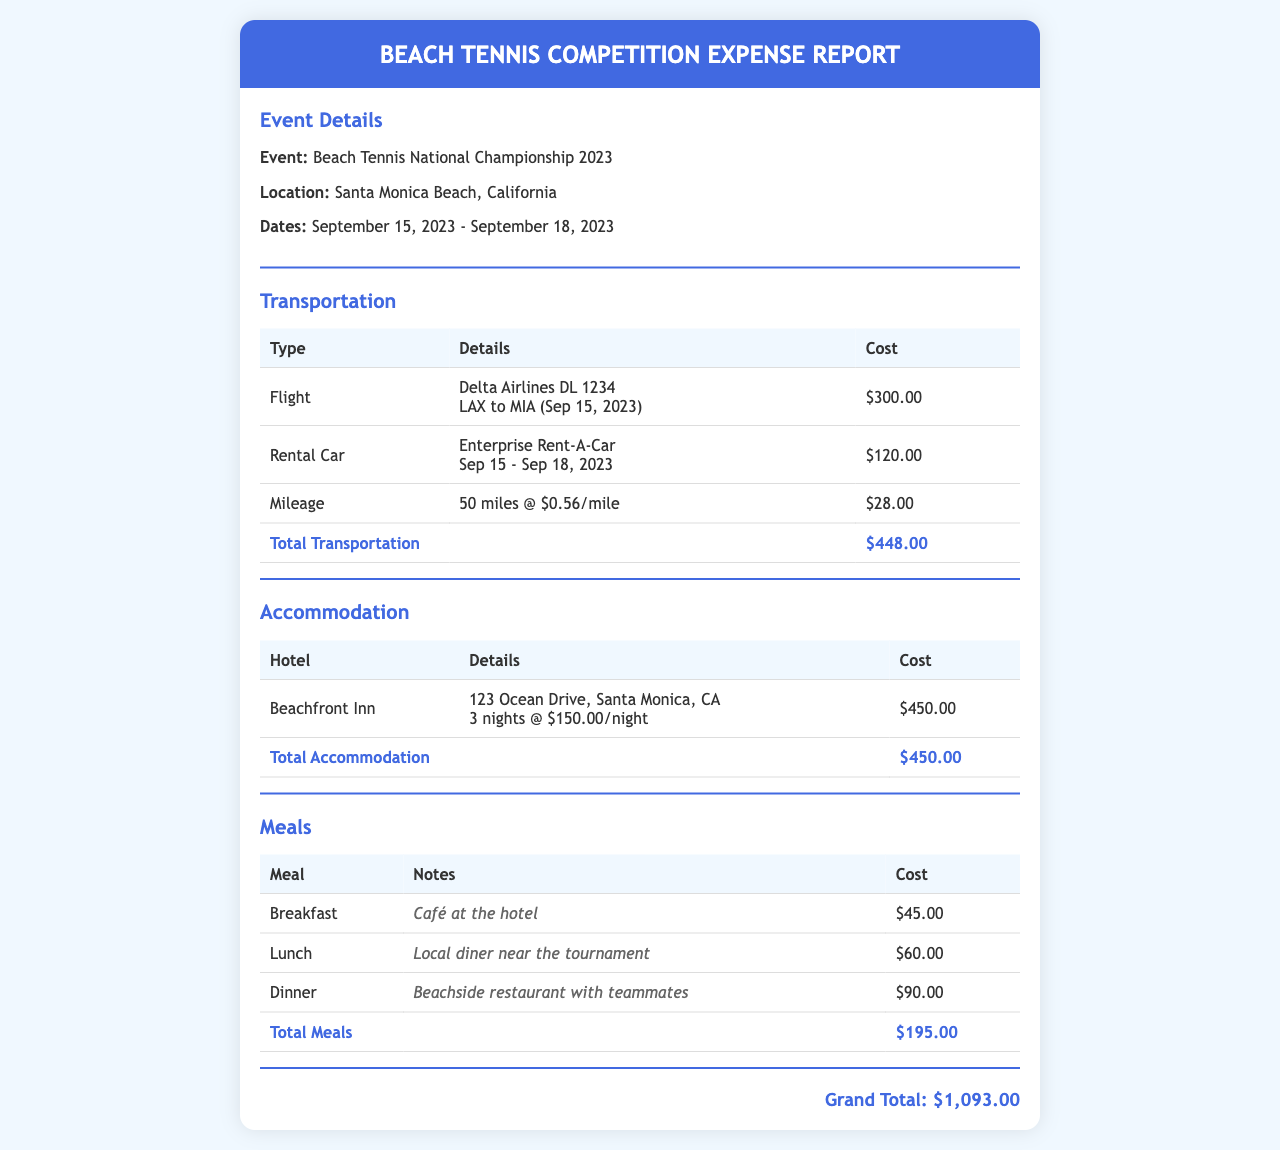What is the event name? The event name is specified in the "Event Details" section of the document.
Answer: Beach Tennis National Championship 2023 What is the location of the competition? The location is found in the "Event Details" section of the document.
Answer: Santa Monica Beach, California How much was spent on transportation? The transportation costs are tallied in the "Transportation" section.
Answer: $448.00 How many nights was the accommodation booked? The accommodation details provide the number of nights stayed at the hotel.
Answer: 3 nights What is the cost of the hotel per night? The hotel cost per night is mentioned in the "Accommodation" section.
Answer: $150.00 What were the total meal expenses? The total meal cost is listed in the "Meals" section of the document.
Answer: $195.00 What is the grand total of all expenses? The grand total is calculated based on all sections of the document.
Answer: $1,093.00 What transportation method was used for the flight? The flight details under the "Transportation" section specify the airline used.
Answer: Delta Airlines What is the date range of the event? The dates for the event are provided in the "Event Details" section of the document.
Answer: September 15, 2023 - September 18, 2023 